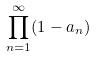<formula> <loc_0><loc_0><loc_500><loc_500>\prod _ { n = 1 } ^ { \infty } ( 1 - a _ { n } )</formula> 